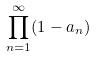<formula> <loc_0><loc_0><loc_500><loc_500>\prod _ { n = 1 } ^ { \infty } ( 1 - a _ { n } )</formula> 